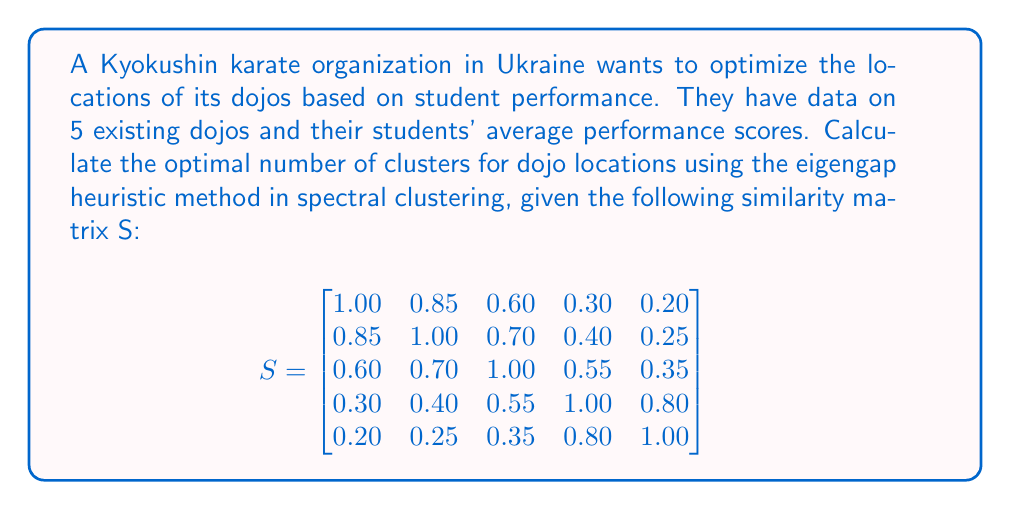Can you answer this question? To solve this problem using the eigengap heuristic method in spectral clustering, we'll follow these steps:

1. Compute the Laplacian matrix L:
   First, calculate the degree matrix D:
   $$D = \text{diag}(2.95, 3.20, 3.20, 3.05, 2.60)$$
   Then, compute L = D - S:
   $$L = \begin{bmatrix}
   1.95 & -0.85 & -0.60 & -0.30 & -0.20 \\
   -0.85 & 2.20 & -0.70 & -0.40 & -0.25 \\
   -0.60 & -0.70 & 2.20 & -0.55 & -0.35 \\
   -0.30 & -0.40 & -0.55 & 2.05 & -0.80 \\
   -0.20 & -0.25 & -0.35 & -0.80 & 1.60
   \end{bmatrix}$$

2. Calculate the eigenvalues of L:
   Using a computational tool, we find the eigenvalues:
   $$\lambda_1 \approx 0.0000$$
   $$\lambda_2 \approx 0.4946$$
   $$\lambda_3 \approx 1.3154$$
   $$\lambda_4 \approx 2.7900$$
   $$\lambda_5 \approx 5.4000$$

3. Compute the eigengaps:
   $$\text{gap}_1 = \lambda_2 - \lambda_1 \approx 0.4946$$
   $$\text{gap}_2 = \lambda_3 - \lambda_2 \approx 0.8208$$
   $$\text{gap}_3 = \lambda_4 - \lambda_3 \approx 1.4746$$
   $$\text{gap}_4 = \lambda_5 - \lambda_4 \approx 2.6100$$

4. Find the largest eigengap:
   The largest eigengap is $\text{gap}_4 \approx 2.6100$

5. Determine the optimal number of clusters:
   The optimal number of clusters is the index of the largest eigengap plus one.
   In this case, it's 4 + 1 = 5.
Answer: 5 clusters 